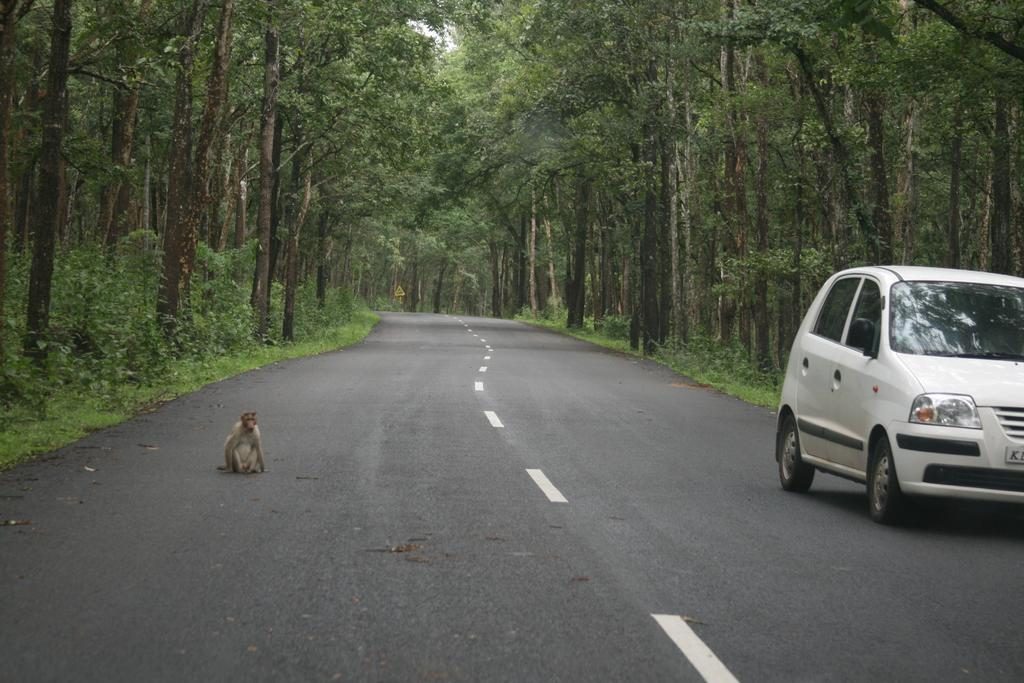What is the main subject of the image? The main subject of the image is a car. What else can be seen on the road in the image? There is a monkey on the road in the image. What is present near the road in the image? There is a signboard in the image. What type of vegetation is visible in the image? There are plants in the image. What can be seen in the background of the image? There are trees visible in the background of the image. What type of floor can be seen in the image? There is no floor visible in the image; it is an outdoor scene with a road, plants, and trees. 